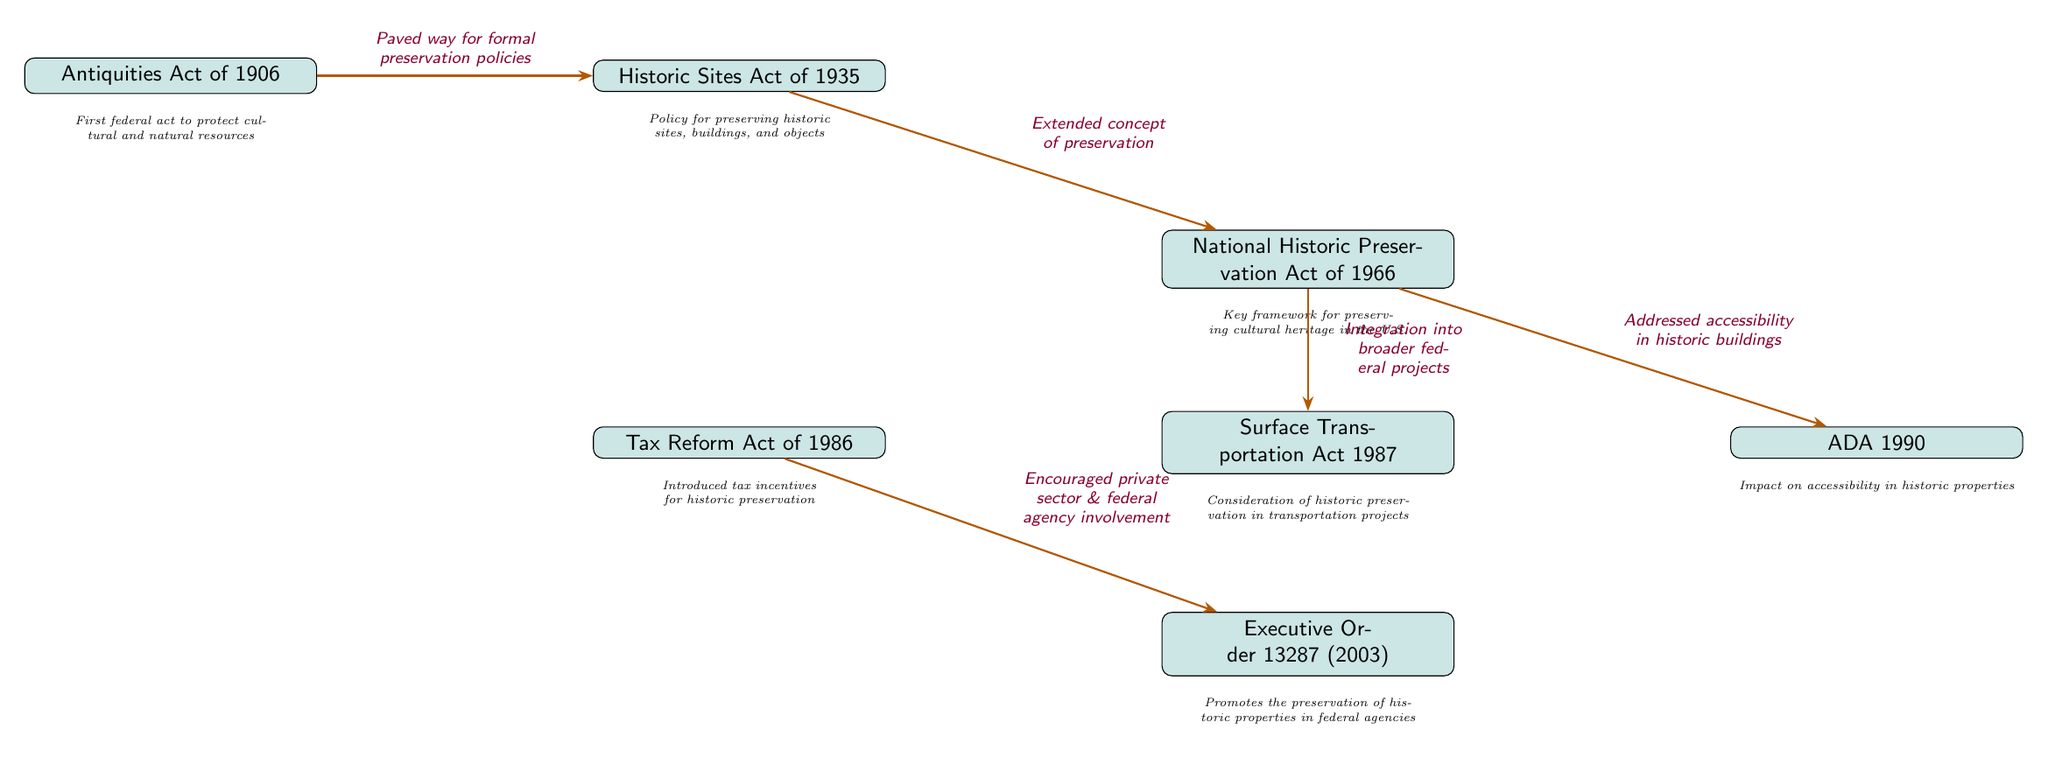What is the first federal act to protect cultural resources? The diagram indicates that the first federal act for cultural and natural resources protection is the Antiquities Act of 1906.
Answer: Antiquities Act of 1906 How many key legislative milestones are represented in the diagram? By counting the nodes in the diagram, we find there are a total of six significant legislative milestones illustrated.
Answer: 6 What milestone introduced tax incentives for historic preservation? The diagram shows that the Tax Reform Act of 1986 is the legislation that introduced tax incentives specifically for historic preservation.
Answer: Tax Reform Act of 1986 Which act extended the concept of preservation from the Historic Sites Act? The arrow from the Historic Sites Act of 1935 points to the National Historic Preservation Act of 1966, indicating that this latter act extended the idea of preservation.
Answer: National Historic Preservation Act of 1966 What legislation addresses accessibility in historic buildings? The diagram connects the National Historic Preservation Act of 1966 to the ADA 1990, signifying that the ADA addressed accessibility issues in historic properties.
Answer: ADA 1990 What does Executive Order 13287 (2003) promote? The description next to the Executive Order 13287 (2003) states that it promotes the preservation of historic properties in federal agencies.
Answer: Preservation of historic properties in federal agencies Which two acts are connected by considering historic preservation in transportation projects? The Surface Transportation Act of 1987 is linked to the National Historic Preservation Act of 1966 through the arrow that indicates integration into broader federal projects, suggesting a relationship between historic preservation and transportation.
Answer: Surface Transportation Act 1987 and National Historic Preservation Act of 1966 What act was established in 1966 and serves as a key framework for preserving cultural heritage in the U.S.? The diagram specifically identifies the National Historic Preservation Act of 1966 as the key framework for this purpose.
Answer: National Historic Preservation Act of 1966 